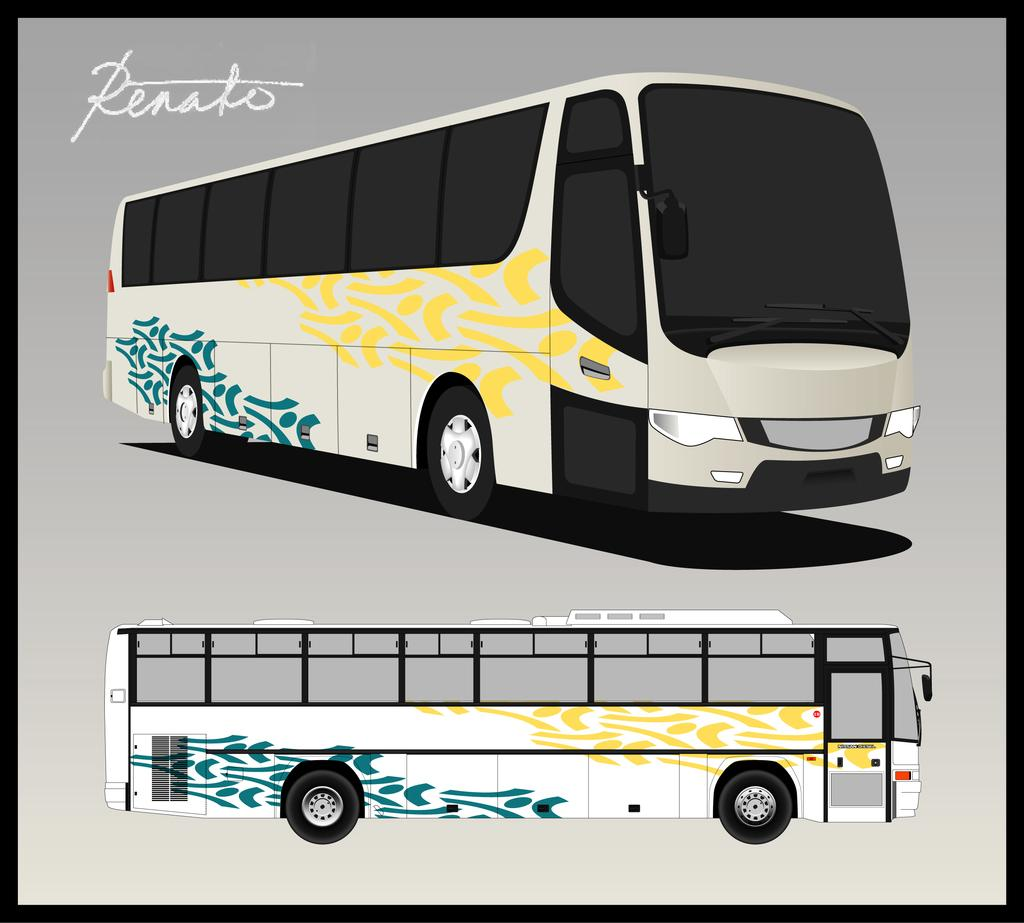<image>
Describe the image concisely. An artist rendering of a commercial bus signed by Renato. 